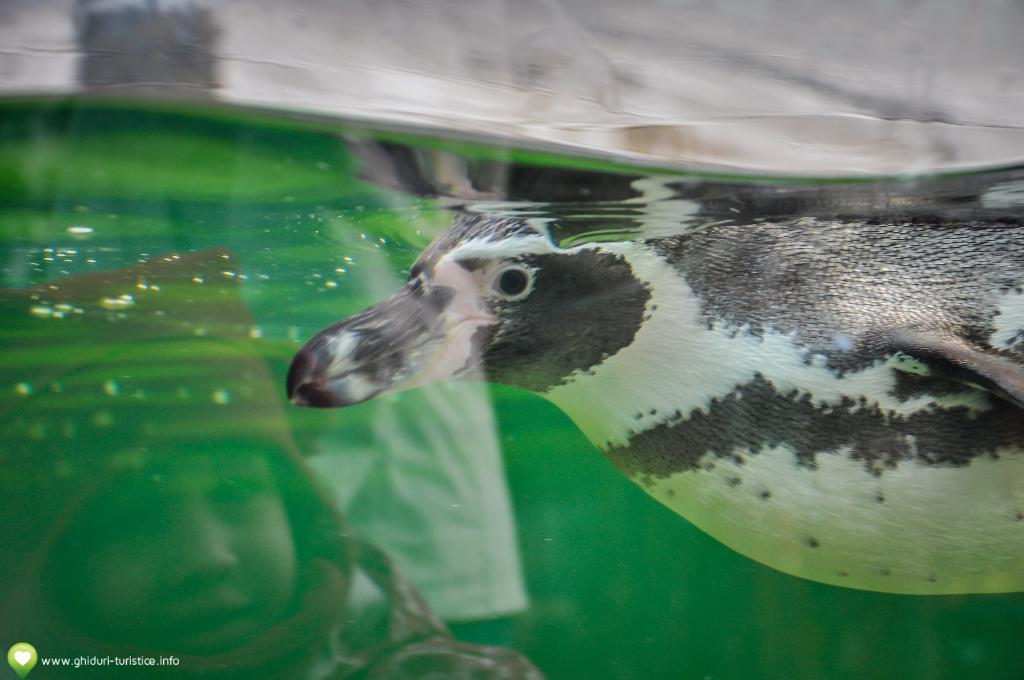What is present in the image? There is water in the image. Is there any living creature visible in the water? Yes, there is an animal inside the water. Can you describe any additional features or elements in the image? There is a watermark in the left corner of the image. What type of spot can be seen on the animal's back in the image? There is no mention of a spot on the animal's back in the image. How is the spade being used in the image? There is no spade present in the image. 